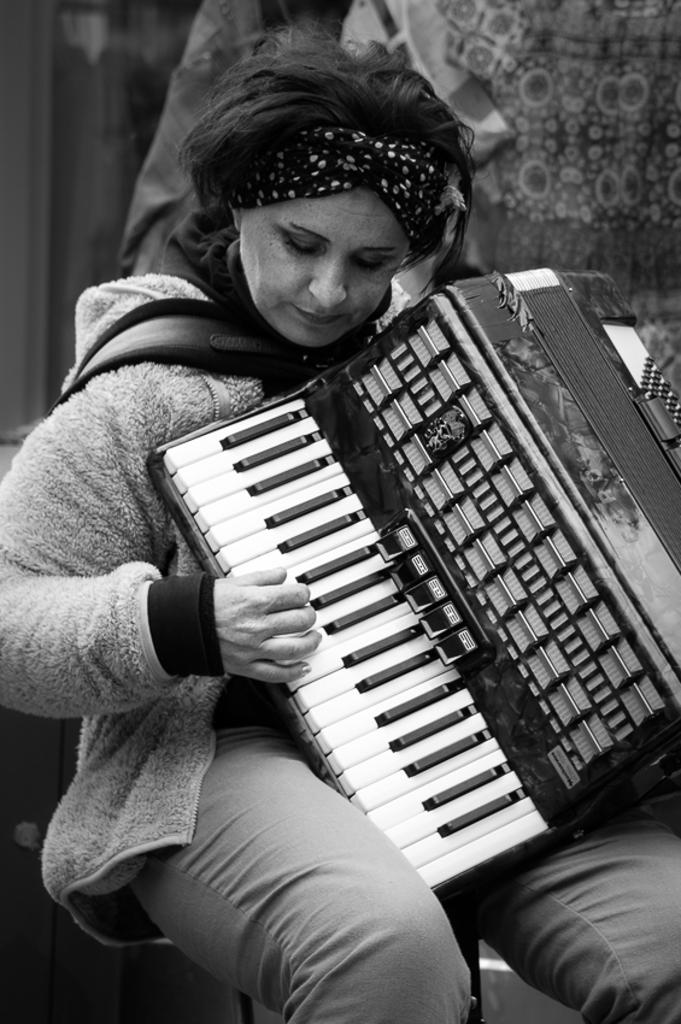What is the color scheme of the image? The image is in black and white. Who is the main subject in the image? There is a woman in the image. What is the woman doing in the image? The woman is playing a musical instrument. What type of clothing is the woman wearing on her upper body? The woman is wearing a sweater. What type of clothing is the woman wearing on her lower body? The woman is wearing trousers. What type of steel is used to construct the jail in the image? There is no jail present in the image, and therefore no steel construction can be observed. Can you describe the curve of the woman's hair in the image? The image is in black and white, so it is difficult to determine the curve of the woman's hair. 